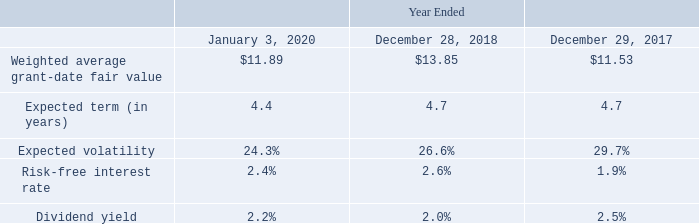Stock Options
Stock options are granted with exercise prices equal to the fair market value of Leidos' common stock on the date of grant and for terms not greater than ten years. Stock options have a term of seven years and a vesting period of four years, except for stock options granted to the Company's outside directors, which have a vesting period of the earlier of one year from grant date or the next annual meeting of stockholders following grant date.
The fair value of the Company's stock option awards is estimated on the date of grant using the Black-Scholes- Merton option-pricing model. The fair value of the Company's stock option awards to employees are expensed on a straight-line basis over the vesting period of four years, except for stock options granted to the Company's outside directors, which is recognized over the vesting period of one year or less.
During fiscal 2017, the Company ceased the usage of peer group volatility, as an input into its blended approach to measure expected volatility, and increased the reliance on historical volatility. The revised blended approach includes the Company's weighted average historical and implied volatilities. The Company continued the use of this approach during fiscal 2018 and fiscal 2019.
The risk-free rate is derived using the yield curve of a zero-coupon U.S. Treasury bond with a maturity equal to the expected term of the stock option on the grant date. During fiscal 2017 and fiscal 2018, Leidos utilized the simplified method for the expected term, which represented an appropriate period of time that the options granted were expected to remain outstanding between the weighted-average vesting period and end of the respective contractual term.
Upon re-examining the Company's exercise history, the methodology used to calculate the expected term changed in fiscal 2019. Based on actual historical settlement data, the midpoint scenario is utilized with a one-year grant date filter assumption for outstanding options. The Company uses historical data to estimate forfeitures and was derived in the same manner as in the prior years presented.
The weighted average grant-date fair value and assumptions used to determine fair value of stock options granted for the periods presented were as follows:
Which model is used to value company's stock option? Black-scholes- merton option-pricing model. When did the Company ceased the usage of peer group volatility? During fiscal 2017. What was the Weighted average grant-date fair value in 2018 and 2017 respectively? $13.85, $11.53. In which year was Weighted average grant-date fair value less than 13.00? Locate and analyze weighted average grant-date fair value in row 4
answer: 2020, 2017. What was the average Expected volatility in 2018 and 2017?
Answer scale should be: percent. (26.6 + 29.7) / 2
Answer: 28.15. What was the change in the Risk-free interest rate from 2017 to 2018?
Answer scale should be: percent. 2.6 - 1.9
Answer: 0.7. 